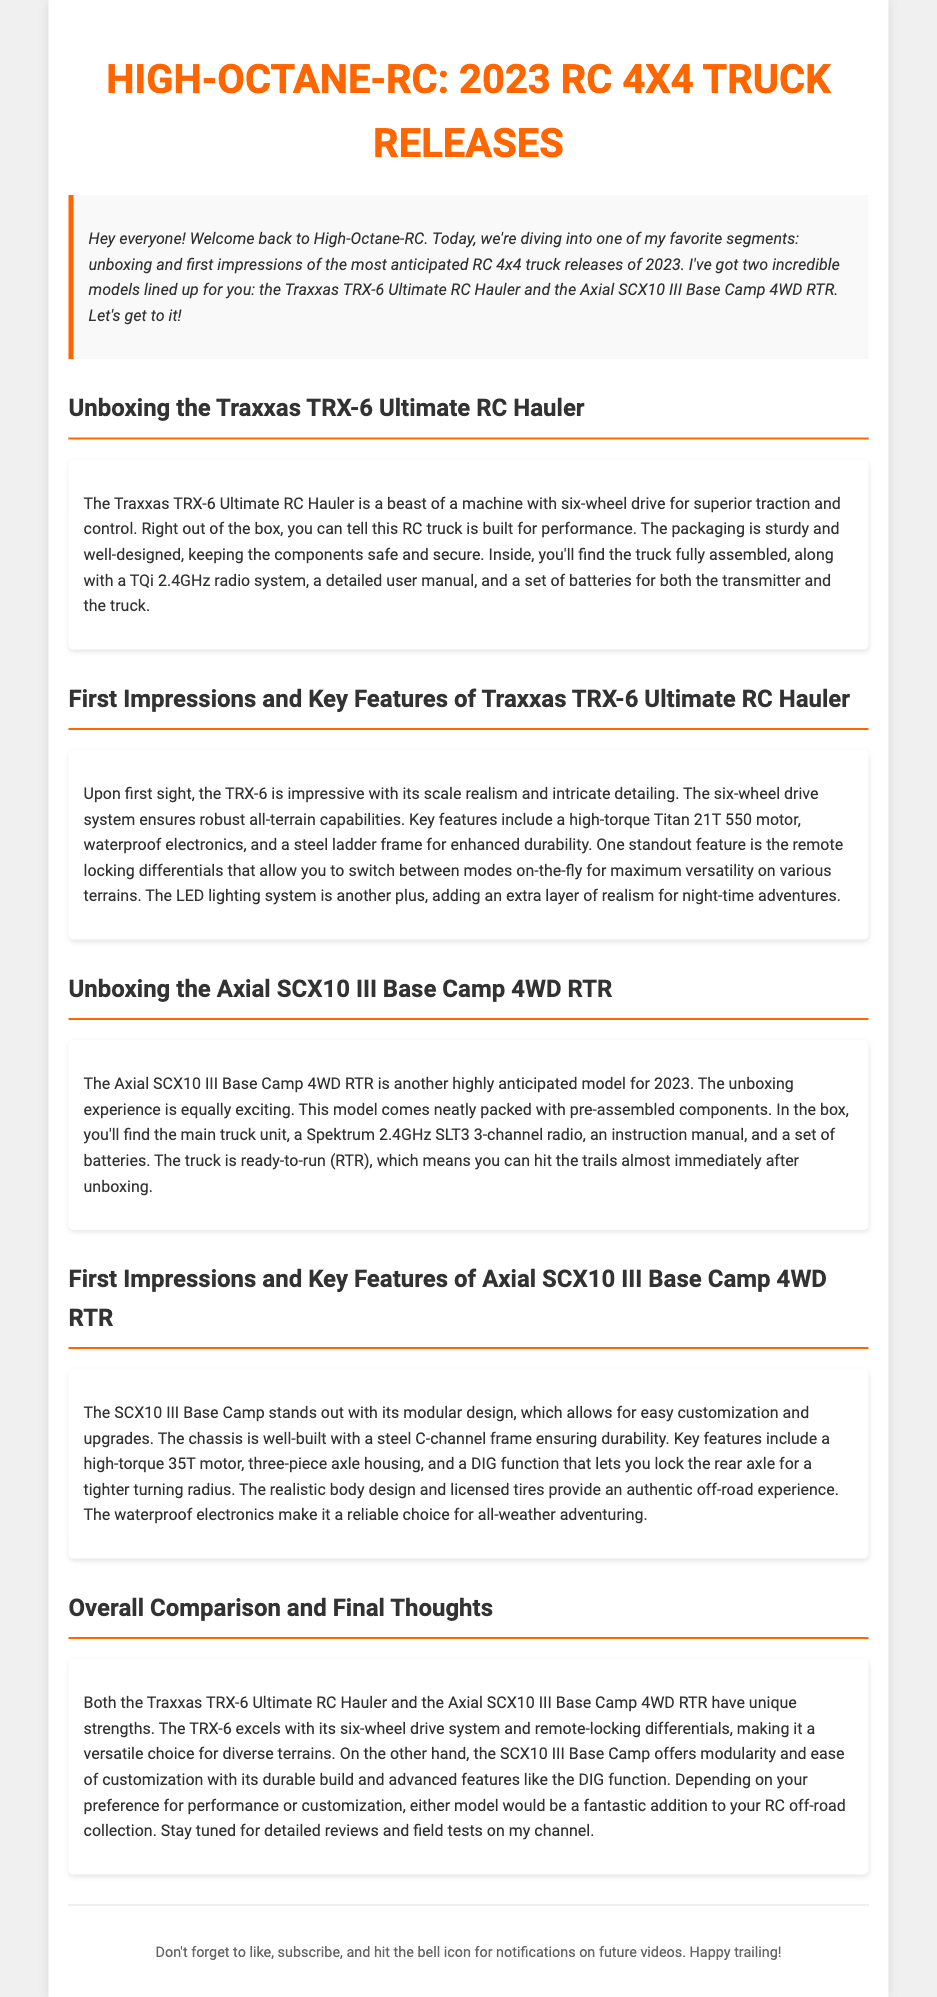What does the TRX-6 feature? The TRX-6 features a six-wheel drive system for superior traction and control.
Answer: six-wheel drive system What is included in the Traxxas TRX-6 package? The Traxxas TRX-6 package includes a TQi 2.4GHz radio system, a detailed user manual, and batteries.
Answer: TQi 2.4GHz radio system, detailed user manual, batteries What is the motor type in the Axial SCX10 III? The Axial SCX10 III is equipped with a high-torque 35T motor.
Answer: high-torque 35T motor How does the TRX-6 excel in versatility? The TRX-6 excels in versatility with its remote locking differentials for various terrains.
Answer: remote locking differentials What aspect of the SCX10 III allows for customization? The SCX10 III has a modular design that allows for easy customization and upgrades.
Answer: modular design What is the main build material of the SCX10 III chassis? The SCX10 III chassis is primarily built using a steel C-channel frame.
Answer: steel C-channel frame How many models are unboxed in the document? The document features two models that are unboxed.
Answer: two models Which model offers a DIG function? The Axial SCX10 III Base Camp 4WD RTR offers a DIG function.
Answer: Axial SCX10 III Base Camp 4WD RTR What type of electrical components does the TRX-6 include? The TRX-6 includes waterproof electronics.
Answer: waterproof electronics 